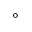Convert formula to latex. <formula><loc_0><loc_0><loc_500><loc_500>^ { \circ }</formula> 